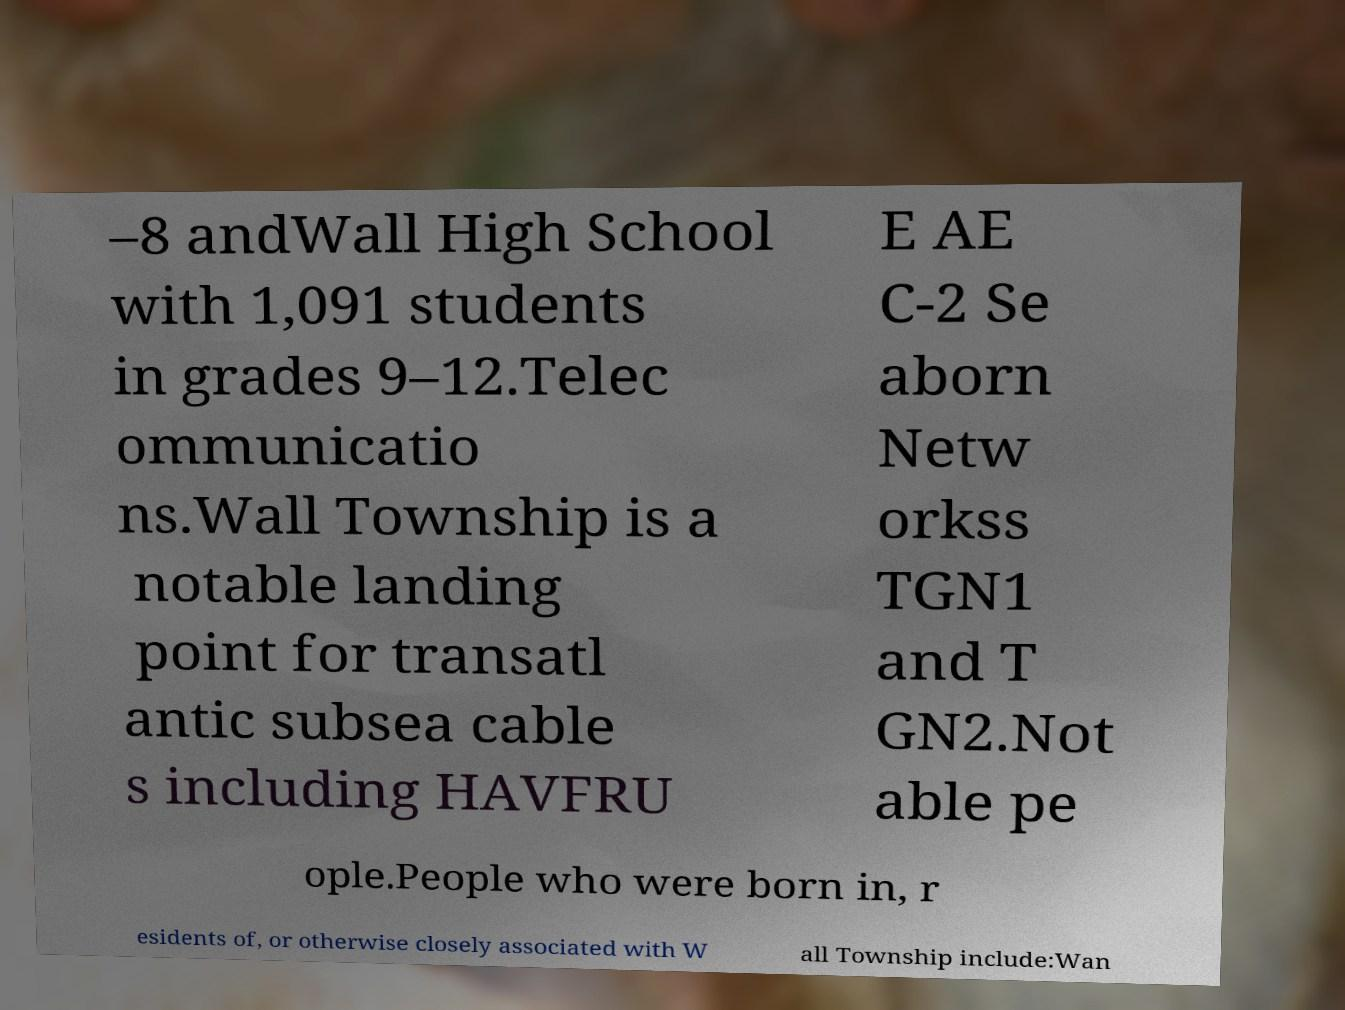Please read and relay the text visible in this image. What does it say? –8 andWall High School with 1,091 students in grades 9–12.Telec ommunicatio ns.Wall Township is a notable landing point for transatl antic subsea cable s including HAVFRU E AE C-2 Se aborn Netw orkss TGN1 and T GN2.Not able pe ople.People who were born in, r esidents of, or otherwise closely associated with W all Township include:Wan 